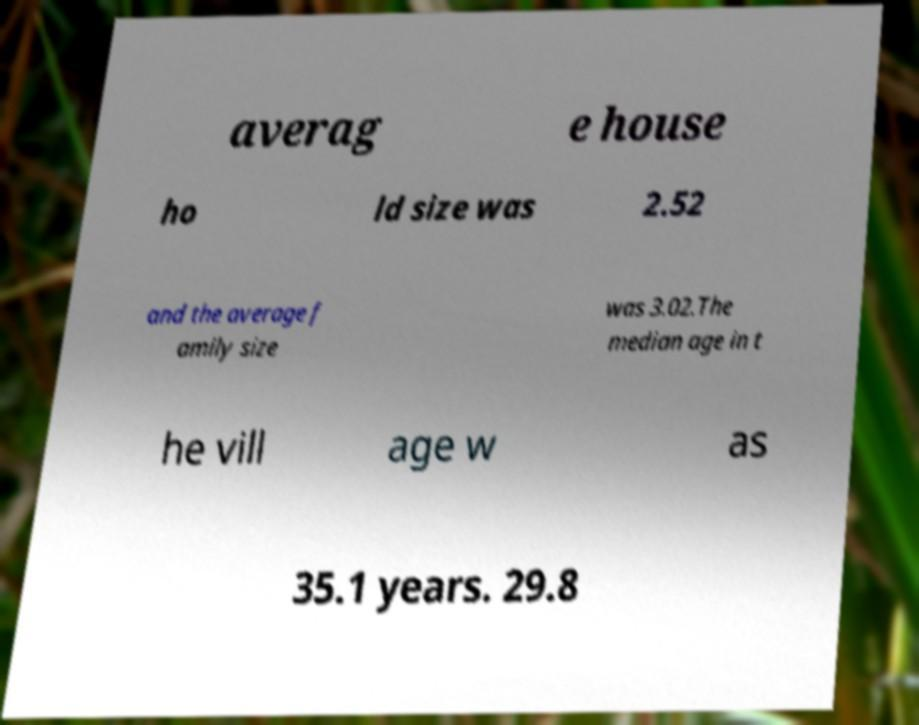Can you read and provide the text displayed in the image?This photo seems to have some interesting text. Can you extract and type it out for me? averag e house ho ld size was 2.52 and the average f amily size was 3.02.The median age in t he vill age w as 35.1 years. 29.8 